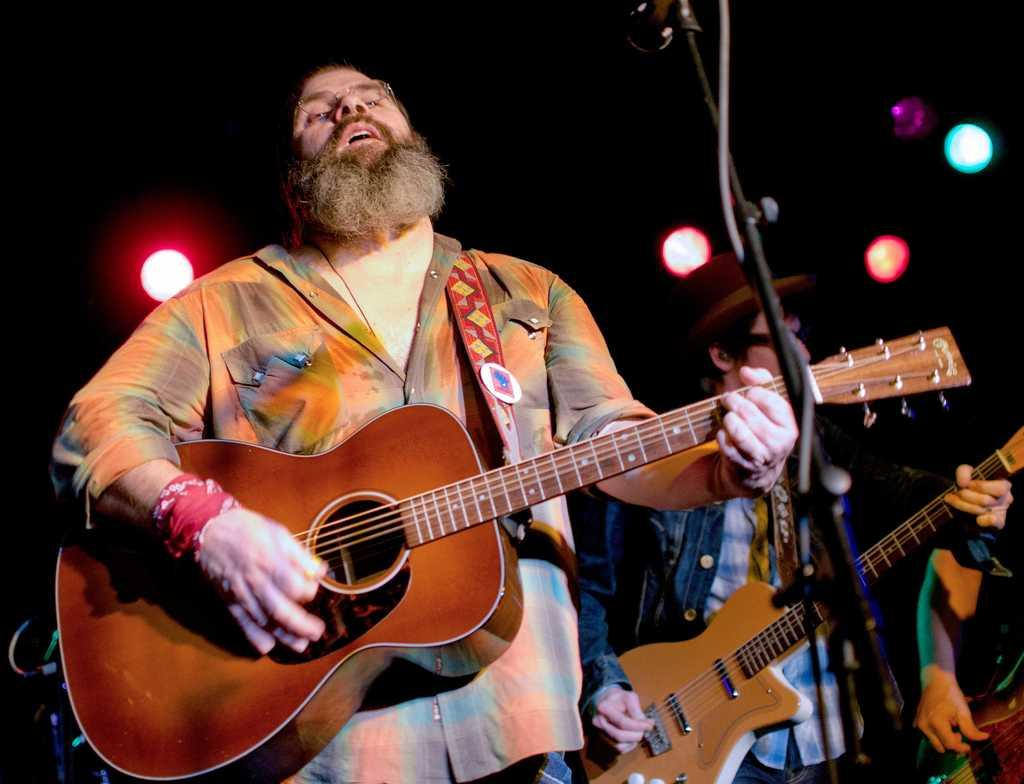What is the main activity being performed by the person in the image? There is a person playing a guitar in the image. Are there any other people performing the same activity in the image? Yes, there is another person playing a guitar on the right side of the image. What type of metal can be seen in the wilderness in the image? There is no metal or wilderness present in the image; it features two people playing guitars. 